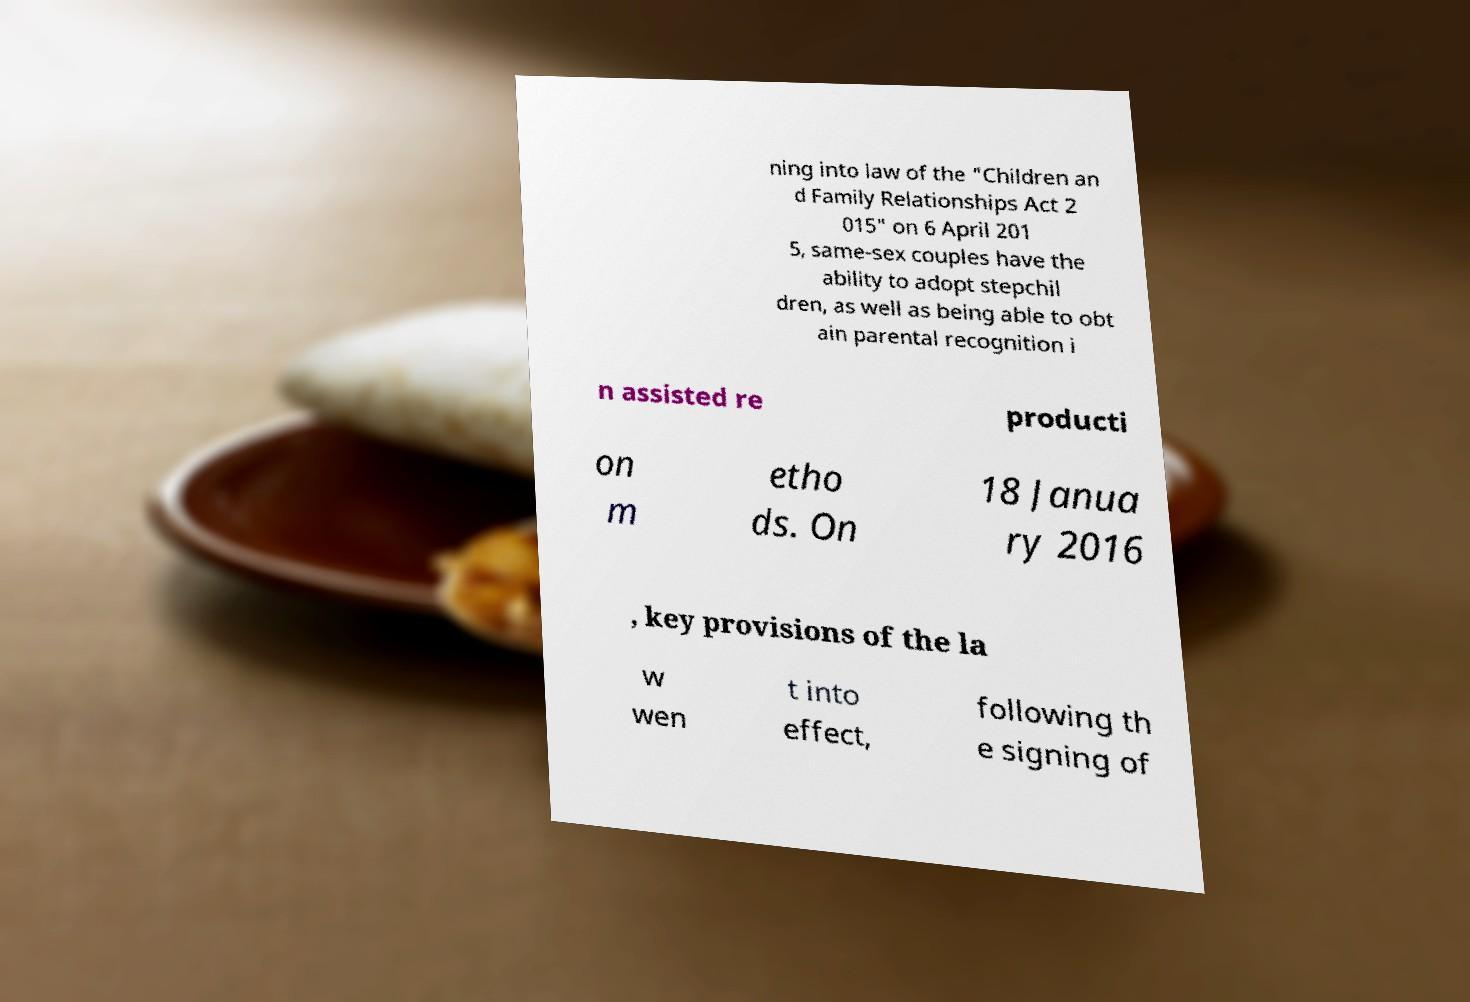Please identify and transcribe the text found in this image. ning into law of the "Children an d Family Relationships Act 2 015" on 6 April 201 5, same-sex couples have the ability to adopt stepchil dren, as well as being able to obt ain parental recognition i n assisted re producti on m etho ds. On 18 Janua ry 2016 , key provisions of the la w wen t into effect, following th e signing of 